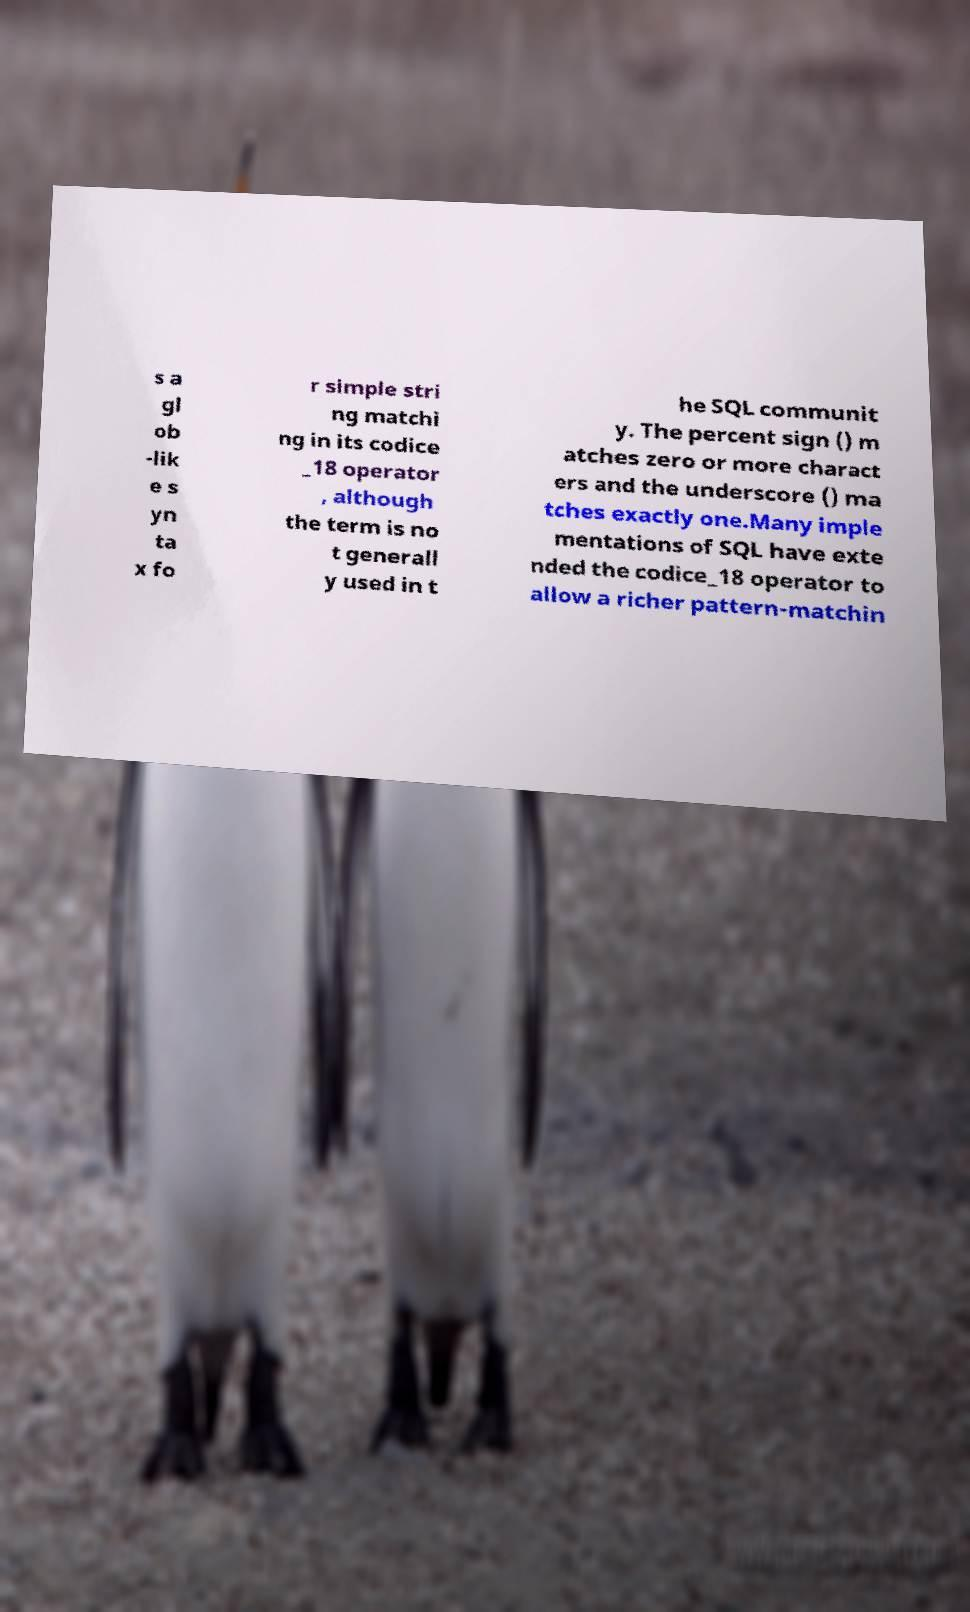Could you assist in decoding the text presented in this image and type it out clearly? s a gl ob -lik e s yn ta x fo r simple stri ng matchi ng in its codice _18 operator , although the term is no t generall y used in t he SQL communit y. The percent sign () m atches zero or more charact ers and the underscore () ma tches exactly one.Many imple mentations of SQL have exte nded the codice_18 operator to allow a richer pattern-matchin 